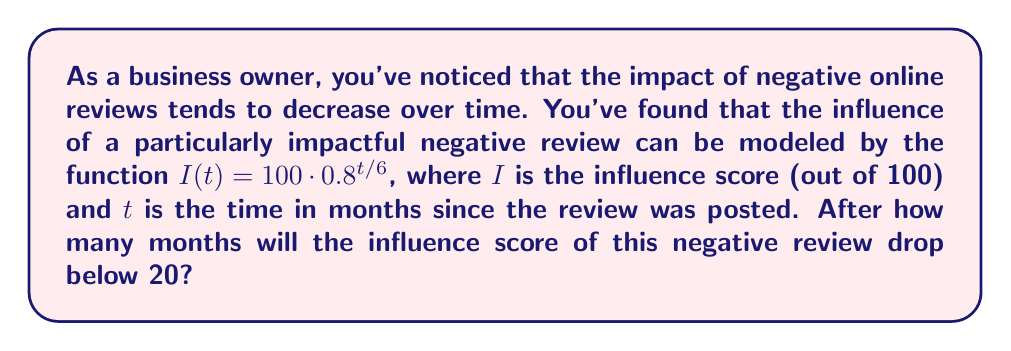Give your solution to this math problem. To solve this problem, we need to use logarithms to isolate the variable $t$. Let's approach this step-by-step:

1) We want to find $t$ when $I(t) < 20$. So, we can set up the equation:
   
   $20 = 100 \cdot 0.8^{t/6}$

2) Divide both sides by 100:
   
   $0.2 = 0.8^{t/6}$

3) Take the natural logarithm of both sides:
   
   $\ln(0.2) = \ln(0.8^{t/6})$

4) Using the logarithm property $\ln(a^b) = b\ln(a)$:
   
   $\ln(0.2) = \frac{t}{6} \ln(0.8)$

5) Multiply both sides by 6:
   
   $6\ln(0.2) = t \ln(0.8)$

6) Divide both sides by $\ln(0.8)$:
   
   $t = \frac{6\ln(0.2)}{\ln(0.8)}$

7) Calculate the value (you can use a calculator for this):
   
   $t \approx 18.85$ months

8) Since we're asking after how many months the score will drop below 20, we need to round up to the next whole month.
Answer: The influence score of the negative review will drop below 20 after 19 months. 